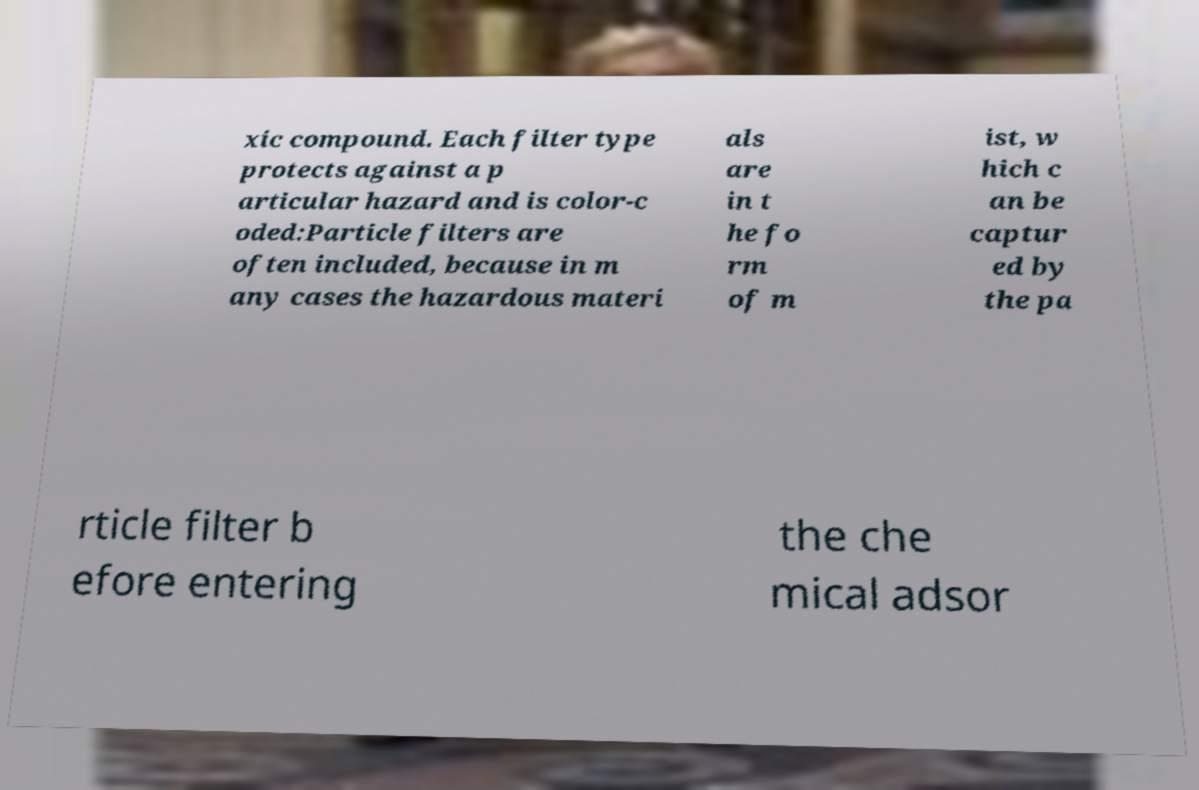What messages or text are displayed in this image? I need them in a readable, typed format. xic compound. Each filter type protects against a p articular hazard and is color-c oded:Particle filters are often included, because in m any cases the hazardous materi als are in t he fo rm of m ist, w hich c an be captur ed by the pa rticle filter b efore entering the che mical adsor 